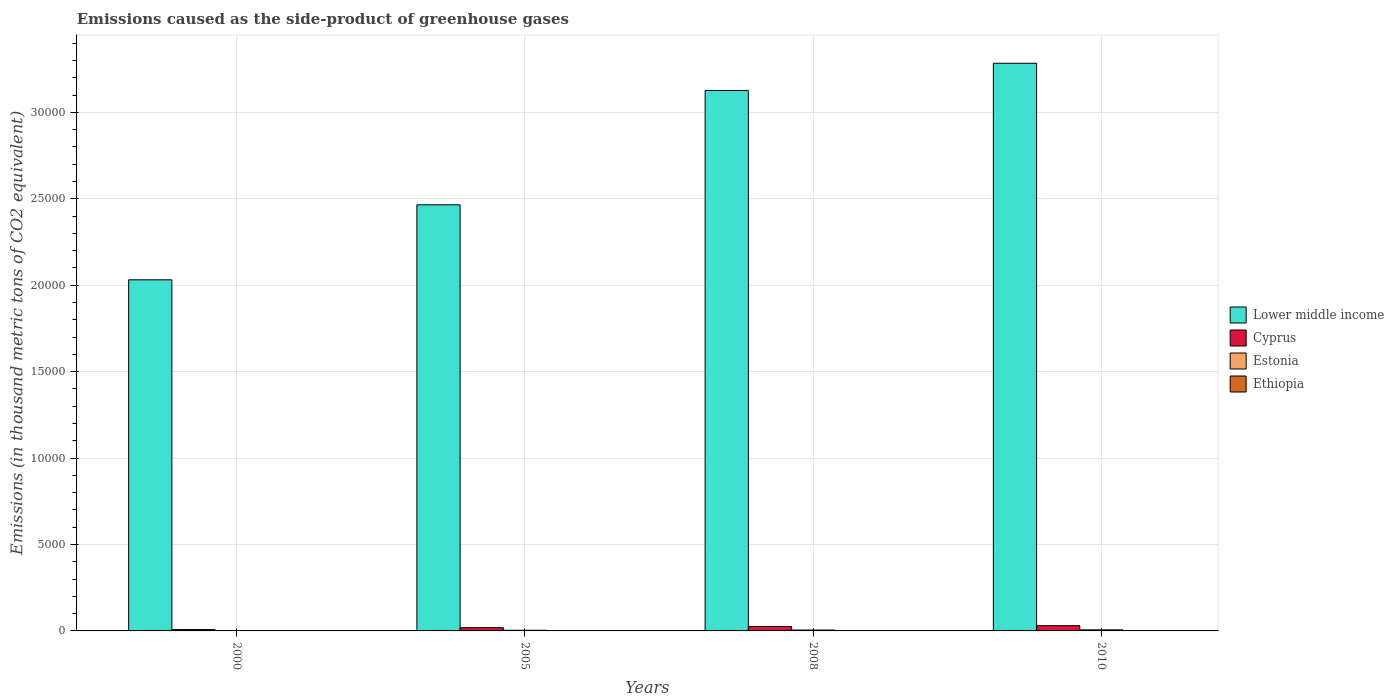How many different coloured bars are there?
Make the answer very short. 4. How many groups of bars are there?
Offer a very short reply. 4. Are the number of bars per tick equal to the number of legend labels?
Make the answer very short. Yes. How many bars are there on the 2nd tick from the left?
Provide a short and direct response. 4. What is the label of the 4th group of bars from the left?
Offer a terse response. 2010. In how many cases, is the number of bars for a given year not equal to the number of legend labels?
Your answer should be very brief. 0. What is the emissions caused as the side-product of greenhouse gases in Ethiopia in 2005?
Ensure brevity in your answer.  10.3. Across all years, what is the minimum emissions caused as the side-product of greenhouse gases in Lower middle income?
Your response must be concise. 2.03e+04. What is the total emissions caused as the side-product of greenhouse gases in Ethiopia in the graph?
Keep it short and to the point. 43.2. What is the difference between the emissions caused as the side-product of greenhouse gases in Ethiopia in 2000 and that in 2008?
Keep it short and to the point. -9.7. What is the difference between the emissions caused as the side-product of greenhouse gases in Lower middle income in 2008 and the emissions caused as the side-product of greenhouse gases in Cyprus in 2005?
Make the answer very short. 3.11e+04. In the year 2005, what is the difference between the emissions caused as the side-product of greenhouse gases in Cyprus and emissions caused as the side-product of greenhouse gases in Ethiopia?
Keep it short and to the point. 178. In how many years, is the emissions caused as the side-product of greenhouse gases in Cyprus greater than 22000 thousand metric tons?
Provide a short and direct response. 0. What is the ratio of the emissions caused as the side-product of greenhouse gases in Ethiopia in 2005 to that in 2008?
Provide a succinct answer. 0.77. Is the emissions caused as the side-product of greenhouse gases in Ethiopia in 2000 less than that in 2008?
Your response must be concise. Yes. What is the difference between the highest and the second highest emissions caused as the side-product of greenhouse gases in Lower middle income?
Offer a terse response. 1576. What is the difference between the highest and the lowest emissions caused as the side-product of greenhouse gases in Lower middle income?
Your answer should be compact. 1.25e+04. In how many years, is the emissions caused as the side-product of greenhouse gases in Lower middle income greater than the average emissions caused as the side-product of greenhouse gases in Lower middle income taken over all years?
Your response must be concise. 2. Is the sum of the emissions caused as the side-product of greenhouse gases in Cyprus in 2005 and 2008 greater than the maximum emissions caused as the side-product of greenhouse gases in Estonia across all years?
Make the answer very short. Yes. What does the 3rd bar from the left in 2008 represents?
Your response must be concise. Estonia. What does the 1st bar from the right in 2010 represents?
Provide a succinct answer. Ethiopia. Is it the case that in every year, the sum of the emissions caused as the side-product of greenhouse gases in Lower middle income and emissions caused as the side-product of greenhouse gases in Cyprus is greater than the emissions caused as the side-product of greenhouse gases in Estonia?
Provide a short and direct response. Yes. How many years are there in the graph?
Make the answer very short. 4. Are the values on the major ticks of Y-axis written in scientific E-notation?
Make the answer very short. No. Does the graph contain any zero values?
Make the answer very short. No. Does the graph contain grids?
Provide a succinct answer. Yes. Where does the legend appear in the graph?
Your answer should be very brief. Center right. How many legend labels are there?
Ensure brevity in your answer.  4. How are the legend labels stacked?
Offer a terse response. Vertical. What is the title of the graph?
Give a very brief answer. Emissions caused as the side-product of greenhouse gases. Does "Sint Maarten (Dutch part)" appear as one of the legend labels in the graph?
Provide a succinct answer. No. What is the label or title of the Y-axis?
Give a very brief answer. Emissions (in thousand metric tons of CO2 equivalent). What is the Emissions (in thousand metric tons of CO2 equivalent) in Lower middle income in 2000?
Give a very brief answer. 2.03e+04. What is the Emissions (in thousand metric tons of CO2 equivalent) in Cyprus in 2000?
Your answer should be very brief. 78.4. What is the Emissions (in thousand metric tons of CO2 equivalent) of Lower middle income in 2005?
Your answer should be very brief. 2.47e+04. What is the Emissions (in thousand metric tons of CO2 equivalent) in Cyprus in 2005?
Your response must be concise. 188.3. What is the Emissions (in thousand metric tons of CO2 equivalent) of Estonia in 2005?
Your answer should be compact. 39.4. What is the Emissions (in thousand metric tons of CO2 equivalent) of Ethiopia in 2005?
Offer a very short reply. 10.3. What is the Emissions (in thousand metric tons of CO2 equivalent) in Lower middle income in 2008?
Your response must be concise. 3.13e+04. What is the Emissions (in thousand metric tons of CO2 equivalent) in Cyprus in 2008?
Your answer should be very brief. 256.1. What is the Emissions (in thousand metric tons of CO2 equivalent) in Estonia in 2008?
Provide a short and direct response. 53.3. What is the Emissions (in thousand metric tons of CO2 equivalent) of Lower middle income in 2010?
Offer a very short reply. 3.28e+04. What is the Emissions (in thousand metric tons of CO2 equivalent) in Cyprus in 2010?
Keep it short and to the point. 304. What is the Emissions (in thousand metric tons of CO2 equivalent) in Estonia in 2010?
Your answer should be very brief. 63. What is the Emissions (in thousand metric tons of CO2 equivalent) in Ethiopia in 2010?
Keep it short and to the point. 16. Across all years, what is the maximum Emissions (in thousand metric tons of CO2 equivalent) in Lower middle income?
Offer a terse response. 3.28e+04. Across all years, what is the maximum Emissions (in thousand metric tons of CO2 equivalent) of Cyprus?
Ensure brevity in your answer.  304. Across all years, what is the maximum Emissions (in thousand metric tons of CO2 equivalent) in Ethiopia?
Your response must be concise. 16. Across all years, what is the minimum Emissions (in thousand metric tons of CO2 equivalent) of Lower middle income?
Ensure brevity in your answer.  2.03e+04. Across all years, what is the minimum Emissions (in thousand metric tons of CO2 equivalent) in Cyprus?
Give a very brief answer. 78.4. Across all years, what is the minimum Emissions (in thousand metric tons of CO2 equivalent) in Estonia?
Make the answer very short. 13.3. Across all years, what is the minimum Emissions (in thousand metric tons of CO2 equivalent) in Ethiopia?
Keep it short and to the point. 3.6. What is the total Emissions (in thousand metric tons of CO2 equivalent) of Lower middle income in the graph?
Ensure brevity in your answer.  1.09e+05. What is the total Emissions (in thousand metric tons of CO2 equivalent) of Cyprus in the graph?
Make the answer very short. 826.8. What is the total Emissions (in thousand metric tons of CO2 equivalent) in Estonia in the graph?
Give a very brief answer. 169. What is the total Emissions (in thousand metric tons of CO2 equivalent) in Ethiopia in the graph?
Make the answer very short. 43.2. What is the difference between the Emissions (in thousand metric tons of CO2 equivalent) of Lower middle income in 2000 and that in 2005?
Make the answer very short. -4339.1. What is the difference between the Emissions (in thousand metric tons of CO2 equivalent) of Cyprus in 2000 and that in 2005?
Ensure brevity in your answer.  -109.9. What is the difference between the Emissions (in thousand metric tons of CO2 equivalent) in Estonia in 2000 and that in 2005?
Offer a terse response. -26.1. What is the difference between the Emissions (in thousand metric tons of CO2 equivalent) of Ethiopia in 2000 and that in 2005?
Offer a very short reply. -6.7. What is the difference between the Emissions (in thousand metric tons of CO2 equivalent) of Lower middle income in 2000 and that in 2008?
Make the answer very short. -1.10e+04. What is the difference between the Emissions (in thousand metric tons of CO2 equivalent) in Cyprus in 2000 and that in 2008?
Your response must be concise. -177.7. What is the difference between the Emissions (in thousand metric tons of CO2 equivalent) in Estonia in 2000 and that in 2008?
Give a very brief answer. -40. What is the difference between the Emissions (in thousand metric tons of CO2 equivalent) in Ethiopia in 2000 and that in 2008?
Keep it short and to the point. -9.7. What is the difference between the Emissions (in thousand metric tons of CO2 equivalent) of Lower middle income in 2000 and that in 2010?
Ensure brevity in your answer.  -1.25e+04. What is the difference between the Emissions (in thousand metric tons of CO2 equivalent) in Cyprus in 2000 and that in 2010?
Your answer should be very brief. -225.6. What is the difference between the Emissions (in thousand metric tons of CO2 equivalent) in Estonia in 2000 and that in 2010?
Make the answer very short. -49.7. What is the difference between the Emissions (in thousand metric tons of CO2 equivalent) in Lower middle income in 2005 and that in 2008?
Offer a very short reply. -6613.6. What is the difference between the Emissions (in thousand metric tons of CO2 equivalent) of Cyprus in 2005 and that in 2008?
Provide a succinct answer. -67.8. What is the difference between the Emissions (in thousand metric tons of CO2 equivalent) in Estonia in 2005 and that in 2008?
Your answer should be compact. -13.9. What is the difference between the Emissions (in thousand metric tons of CO2 equivalent) of Lower middle income in 2005 and that in 2010?
Provide a short and direct response. -8189.6. What is the difference between the Emissions (in thousand metric tons of CO2 equivalent) in Cyprus in 2005 and that in 2010?
Your answer should be compact. -115.7. What is the difference between the Emissions (in thousand metric tons of CO2 equivalent) of Estonia in 2005 and that in 2010?
Ensure brevity in your answer.  -23.6. What is the difference between the Emissions (in thousand metric tons of CO2 equivalent) in Ethiopia in 2005 and that in 2010?
Provide a short and direct response. -5.7. What is the difference between the Emissions (in thousand metric tons of CO2 equivalent) of Lower middle income in 2008 and that in 2010?
Ensure brevity in your answer.  -1576. What is the difference between the Emissions (in thousand metric tons of CO2 equivalent) in Cyprus in 2008 and that in 2010?
Your answer should be very brief. -47.9. What is the difference between the Emissions (in thousand metric tons of CO2 equivalent) of Lower middle income in 2000 and the Emissions (in thousand metric tons of CO2 equivalent) of Cyprus in 2005?
Ensure brevity in your answer.  2.01e+04. What is the difference between the Emissions (in thousand metric tons of CO2 equivalent) in Lower middle income in 2000 and the Emissions (in thousand metric tons of CO2 equivalent) in Estonia in 2005?
Your response must be concise. 2.03e+04. What is the difference between the Emissions (in thousand metric tons of CO2 equivalent) in Lower middle income in 2000 and the Emissions (in thousand metric tons of CO2 equivalent) in Ethiopia in 2005?
Your response must be concise. 2.03e+04. What is the difference between the Emissions (in thousand metric tons of CO2 equivalent) of Cyprus in 2000 and the Emissions (in thousand metric tons of CO2 equivalent) of Ethiopia in 2005?
Keep it short and to the point. 68.1. What is the difference between the Emissions (in thousand metric tons of CO2 equivalent) in Lower middle income in 2000 and the Emissions (in thousand metric tons of CO2 equivalent) in Cyprus in 2008?
Your response must be concise. 2.01e+04. What is the difference between the Emissions (in thousand metric tons of CO2 equivalent) in Lower middle income in 2000 and the Emissions (in thousand metric tons of CO2 equivalent) in Estonia in 2008?
Offer a terse response. 2.03e+04. What is the difference between the Emissions (in thousand metric tons of CO2 equivalent) in Lower middle income in 2000 and the Emissions (in thousand metric tons of CO2 equivalent) in Ethiopia in 2008?
Your response must be concise. 2.03e+04. What is the difference between the Emissions (in thousand metric tons of CO2 equivalent) of Cyprus in 2000 and the Emissions (in thousand metric tons of CO2 equivalent) of Estonia in 2008?
Offer a very short reply. 25.1. What is the difference between the Emissions (in thousand metric tons of CO2 equivalent) of Cyprus in 2000 and the Emissions (in thousand metric tons of CO2 equivalent) of Ethiopia in 2008?
Provide a succinct answer. 65.1. What is the difference between the Emissions (in thousand metric tons of CO2 equivalent) in Lower middle income in 2000 and the Emissions (in thousand metric tons of CO2 equivalent) in Cyprus in 2010?
Offer a very short reply. 2.00e+04. What is the difference between the Emissions (in thousand metric tons of CO2 equivalent) in Lower middle income in 2000 and the Emissions (in thousand metric tons of CO2 equivalent) in Estonia in 2010?
Your answer should be compact. 2.03e+04. What is the difference between the Emissions (in thousand metric tons of CO2 equivalent) in Lower middle income in 2000 and the Emissions (in thousand metric tons of CO2 equivalent) in Ethiopia in 2010?
Keep it short and to the point. 2.03e+04. What is the difference between the Emissions (in thousand metric tons of CO2 equivalent) of Cyprus in 2000 and the Emissions (in thousand metric tons of CO2 equivalent) of Estonia in 2010?
Provide a short and direct response. 15.4. What is the difference between the Emissions (in thousand metric tons of CO2 equivalent) of Cyprus in 2000 and the Emissions (in thousand metric tons of CO2 equivalent) of Ethiopia in 2010?
Your answer should be very brief. 62.4. What is the difference between the Emissions (in thousand metric tons of CO2 equivalent) in Lower middle income in 2005 and the Emissions (in thousand metric tons of CO2 equivalent) in Cyprus in 2008?
Keep it short and to the point. 2.44e+04. What is the difference between the Emissions (in thousand metric tons of CO2 equivalent) in Lower middle income in 2005 and the Emissions (in thousand metric tons of CO2 equivalent) in Estonia in 2008?
Provide a succinct answer. 2.46e+04. What is the difference between the Emissions (in thousand metric tons of CO2 equivalent) in Lower middle income in 2005 and the Emissions (in thousand metric tons of CO2 equivalent) in Ethiopia in 2008?
Ensure brevity in your answer.  2.46e+04. What is the difference between the Emissions (in thousand metric tons of CO2 equivalent) in Cyprus in 2005 and the Emissions (in thousand metric tons of CO2 equivalent) in Estonia in 2008?
Your response must be concise. 135. What is the difference between the Emissions (in thousand metric tons of CO2 equivalent) of Cyprus in 2005 and the Emissions (in thousand metric tons of CO2 equivalent) of Ethiopia in 2008?
Make the answer very short. 175. What is the difference between the Emissions (in thousand metric tons of CO2 equivalent) of Estonia in 2005 and the Emissions (in thousand metric tons of CO2 equivalent) of Ethiopia in 2008?
Provide a succinct answer. 26.1. What is the difference between the Emissions (in thousand metric tons of CO2 equivalent) in Lower middle income in 2005 and the Emissions (in thousand metric tons of CO2 equivalent) in Cyprus in 2010?
Offer a terse response. 2.43e+04. What is the difference between the Emissions (in thousand metric tons of CO2 equivalent) in Lower middle income in 2005 and the Emissions (in thousand metric tons of CO2 equivalent) in Estonia in 2010?
Make the answer very short. 2.46e+04. What is the difference between the Emissions (in thousand metric tons of CO2 equivalent) of Lower middle income in 2005 and the Emissions (in thousand metric tons of CO2 equivalent) of Ethiopia in 2010?
Offer a terse response. 2.46e+04. What is the difference between the Emissions (in thousand metric tons of CO2 equivalent) in Cyprus in 2005 and the Emissions (in thousand metric tons of CO2 equivalent) in Estonia in 2010?
Give a very brief answer. 125.3. What is the difference between the Emissions (in thousand metric tons of CO2 equivalent) of Cyprus in 2005 and the Emissions (in thousand metric tons of CO2 equivalent) of Ethiopia in 2010?
Provide a succinct answer. 172.3. What is the difference between the Emissions (in thousand metric tons of CO2 equivalent) of Estonia in 2005 and the Emissions (in thousand metric tons of CO2 equivalent) of Ethiopia in 2010?
Your answer should be compact. 23.4. What is the difference between the Emissions (in thousand metric tons of CO2 equivalent) of Lower middle income in 2008 and the Emissions (in thousand metric tons of CO2 equivalent) of Cyprus in 2010?
Provide a short and direct response. 3.10e+04. What is the difference between the Emissions (in thousand metric tons of CO2 equivalent) of Lower middle income in 2008 and the Emissions (in thousand metric tons of CO2 equivalent) of Estonia in 2010?
Keep it short and to the point. 3.12e+04. What is the difference between the Emissions (in thousand metric tons of CO2 equivalent) in Lower middle income in 2008 and the Emissions (in thousand metric tons of CO2 equivalent) in Ethiopia in 2010?
Your answer should be compact. 3.13e+04. What is the difference between the Emissions (in thousand metric tons of CO2 equivalent) in Cyprus in 2008 and the Emissions (in thousand metric tons of CO2 equivalent) in Estonia in 2010?
Your answer should be very brief. 193.1. What is the difference between the Emissions (in thousand metric tons of CO2 equivalent) in Cyprus in 2008 and the Emissions (in thousand metric tons of CO2 equivalent) in Ethiopia in 2010?
Your answer should be very brief. 240.1. What is the difference between the Emissions (in thousand metric tons of CO2 equivalent) in Estonia in 2008 and the Emissions (in thousand metric tons of CO2 equivalent) in Ethiopia in 2010?
Your response must be concise. 37.3. What is the average Emissions (in thousand metric tons of CO2 equivalent) of Lower middle income per year?
Give a very brief answer. 2.73e+04. What is the average Emissions (in thousand metric tons of CO2 equivalent) in Cyprus per year?
Your answer should be very brief. 206.7. What is the average Emissions (in thousand metric tons of CO2 equivalent) of Estonia per year?
Provide a short and direct response. 42.25. In the year 2000, what is the difference between the Emissions (in thousand metric tons of CO2 equivalent) in Lower middle income and Emissions (in thousand metric tons of CO2 equivalent) in Cyprus?
Keep it short and to the point. 2.02e+04. In the year 2000, what is the difference between the Emissions (in thousand metric tons of CO2 equivalent) of Lower middle income and Emissions (in thousand metric tons of CO2 equivalent) of Estonia?
Your answer should be very brief. 2.03e+04. In the year 2000, what is the difference between the Emissions (in thousand metric tons of CO2 equivalent) of Lower middle income and Emissions (in thousand metric tons of CO2 equivalent) of Ethiopia?
Your answer should be very brief. 2.03e+04. In the year 2000, what is the difference between the Emissions (in thousand metric tons of CO2 equivalent) in Cyprus and Emissions (in thousand metric tons of CO2 equivalent) in Estonia?
Give a very brief answer. 65.1. In the year 2000, what is the difference between the Emissions (in thousand metric tons of CO2 equivalent) in Cyprus and Emissions (in thousand metric tons of CO2 equivalent) in Ethiopia?
Keep it short and to the point. 74.8. In the year 2000, what is the difference between the Emissions (in thousand metric tons of CO2 equivalent) in Estonia and Emissions (in thousand metric tons of CO2 equivalent) in Ethiopia?
Your answer should be compact. 9.7. In the year 2005, what is the difference between the Emissions (in thousand metric tons of CO2 equivalent) in Lower middle income and Emissions (in thousand metric tons of CO2 equivalent) in Cyprus?
Make the answer very short. 2.45e+04. In the year 2005, what is the difference between the Emissions (in thousand metric tons of CO2 equivalent) of Lower middle income and Emissions (in thousand metric tons of CO2 equivalent) of Estonia?
Your answer should be very brief. 2.46e+04. In the year 2005, what is the difference between the Emissions (in thousand metric tons of CO2 equivalent) of Lower middle income and Emissions (in thousand metric tons of CO2 equivalent) of Ethiopia?
Your answer should be compact. 2.46e+04. In the year 2005, what is the difference between the Emissions (in thousand metric tons of CO2 equivalent) in Cyprus and Emissions (in thousand metric tons of CO2 equivalent) in Estonia?
Keep it short and to the point. 148.9. In the year 2005, what is the difference between the Emissions (in thousand metric tons of CO2 equivalent) of Cyprus and Emissions (in thousand metric tons of CO2 equivalent) of Ethiopia?
Provide a succinct answer. 178. In the year 2005, what is the difference between the Emissions (in thousand metric tons of CO2 equivalent) of Estonia and Emissions (in thousand metric tons of CO2 equivalent) of Ethiopia?
Provide a short and direct response. 29.1. In the year 2008, what is the difference between the Emissions (in thousand metric tons of CO2 equivalent) of Lower middle income and Emissions (in thousand metric tons of CO2 equivalent) of Cyprus?
Provide a succinct answer. 3.10e+04. In the year 2008, what is the difference between the Emissions (in thousand metric tons of CO2 equivalent) in Lower middle income and Emissions (in thousand metric tons of CO2 equivalent) in Estonia?
Give a very brief answer. 3.12e+04. In the year 2008, what is the difference between the Emissions (in thousand metric tons of CO2 equivalent) of Lower middle income and Emissions (in thousand metric tons of CO2 equivalent) of Ethiopia?
Your response must be concise. 3.13e+04. In the year 2008, what is the difference between the Emissions (in thousand metric tons of CO2 equivalent) of Cyprus and Emissions (in thousand metric tons of CO2 equivalent) of Estonia?
Offer a terse response. 202.8. In the year 2008, what is the difference between the Emissions (in thousand metric tons of CO2 equivalent) of Cyprus and Emissions (in thousand metric tons of CO2 equivalent) of Ethiopia?
Your response must be concise. 242.8. In the year 2010, what is the difference between the Emissions (in thousand metric tons of CO2 equivalent) in Lower middle income and Emissions (in thousand metric tons of CO2 equivalent) in Cyprus?
Provide a short and direct response. 3.25e+04. In the year 2010, what is the difference between the Emissions (in thousand metric tons of CO2 equivalent) in Lower middle income and Emissions (in thousand metric tons of CO2 equivalent) in Estonia?
Provide a short and direct response. 3.28e+04. In the year 2010, what is the difference between the Emissions (in thousand metric tons of CO2 equivalent) of Lower middle income and Emissions (in thousand metric tons of CO2 equivalent) of Ethiopia?
Ensure brevity in your answer.  3.28e+04. In the year 2010, what is the difference between the Emissions (in thousand metric tons of CO2 equivalent) of Cyprus and Emissions (in thousand metric tons of CO2 equivalent) of Estonia?
Ensure brevity in your answer.  241. In the year 2010, what is the difference between the Emissions (in thousand metric tons of CO2 equivalent) of Cyprus and Emissions (in thousand metric tons of CO2 equivalent) of Ethiopia?
Keep it short and to the point. 288. In the year 2010, what is the difference between the Emissions (in thousand metric tons of CO2 equivalent) in Estonia and Emissions (in thousand metric tons of CO2 equivalent) in Ethiopia?
Ensure brevity in your answer.  47. What is the ratio of the Emissions (in thousand metric tons of CO2 equivalent) in Lower middle income in 2000 to that in 2005?
Provide a short and direct response. 0.82. What is the ratio of the Emissions (in thousand metric tons of CO2 equivalent) in Cyprus in 2000 to that in 2005?
Give a very brief answer. 0.42. What is the ratio of the Emissions (in thousand metric tons of CO2 equivalent) in Estonia in 2000 to that in 2005?
Your answer should be compact. 0.34. What is the ratio of the Emissions (in thousand metric tons of CO2 equivalent) of Ethiopia in 2000 to that in 2005?
Provide a succinct answer. 0.35. What is the ratio of the Emissions (in thousand metric tons of CO2 equivalent) in Lower middle income in 2000 to that in 2008?
Provide a succinct answer. 0.65. What is the ratio of the Emissions (in thousand metric tons of CO2 equivalent) of Cyprus in 2000 to that in 2008?
Keep it short and to the point. 0.31. What is the ratio of the Emissions (in thousand metric tons of CO2 equivalent) of Estonia in 2000 to that in 2008?
Your answer should be compact. 0.25. What is the ratio of the Emissions (in thousand metric tons of CO2 equivalent) in Ethiopia in 2000 to that in 2008?
Your response must be concise. 0.27. What is the ratio of the Emissions (in thousand metric tons of CO2 equivalent) in Lower middle income in 2000 to that in 2010?
Offer a terse response. 0.62. What is the ratio of the Emissions (in thousand metric tons of CO2 equivalent) of Cyprus in 2000 to that in 2010?
Offer a very short reply. 0.26. What is the ratio of the Emissions (in thousand metric tons of CO2 equivalent) in Estonia in 2000 to that in 2010?
Give a very brief answer. 0.21. What is the ratio of the Emissions (in thousand metric tons of CO2 equivalent) of Ethiopia in 2000 to that in 2010?
Your response must be concise. 0.23. What is the ratio of the Emissions (in thousand metric tons of CO2 equivalent) of Lower middle income in 2005 to that in 2008?
Offer a very short reply. 0.79. What is the ratio of the Emissions (in thousand metric tons of CO2 equivalent) in Cyprus in 2005 to that in 2008?
Your answer should be compact. 0.74. What is the ratio of the Emissions (in thousand metric tons of CO2 equivalent) of Estonia in 2005 to that in 2008?
Give a very brief answer. 0.74. What is the ratio of the Emissions (in thousand metric tons of CO2 equivalent) of Ethiopia in 2005 to that in 2008?
Offer a terse response. 0.77. What is the ratio of the Emissions (in thousand metric tons of CO2 equivalent) in Lower middle income in 2005 to that in 2010?
Ensure brevity in your answer.  0.75. What is the ratio of the Emissions (in thousand metric tons of CO2 equivalent) in Cyprus in 2005 to that in 2010?
Your answer should be very brief. 0.62. What is the ratio of the Emissions (in thousand metric tons of CO2 equivalent) in Estonia in 2005 to that in 2010?
Your response must be concise. 0.63. What is the ratio of the Emissions (in thousand metric tons of CO2 equivalent) in Ethiopia in 2005 to that in 2010?
Give a very brief answer. 0.64. What is the ratio of the Emissions (in thousand metric tons of CO2 equivalent) in Cyprus in 2008 to that in 2010?
Your answer should be compact. 0.84. What is the ratio of the Emissions (in thousand metric tons of CO2 equivalent) in Estonia in 2008 to that in 2010?
Ensure brevity in your answer.  0.85. What is the ratio of the Emissions (in thousand metric tons of CO2 equivalent) in Ethiopia in 2008 to that in 2010?
Provide a succinct answer. 0.83. What is the difference between the highest and the second highest Emissions (in thousand metric tons of CO2 equivalent) of Lower middle income?
Ensure brevity in your answer.  1576. What is the difference between the highest and the second highest Emissions (in thousand metric tons of CO2 equivalent) of Cyprus?
Offer a terse response. 47.9. What is the difference between the highest and the second highest Emissions (in thousand metric tons of CO2 equivalent) of Estonia?
Offer a very short reply. 9.7. What is the difference between the highest and the lowest Emissions (in thousand metric tons of CO2 equivalent) in Lower middle income?
Ensure brevity in your answer.  1.25e+04. What is the difference between the highest and the lowest Emissions (in thousand metric tons of CO2 equivalent) in Cyprus?
Your answer should be very brief. 225.6. What is the difference between the highest and the lowest Emissions (in thousand metric tons of CO2 equivalent) in Estonia?
Provide a succinct answer. 49.7. What is the difference between the highest and the lowest Emissions (in thousand metric tons of CO2 equivalent) of Ethiopia?
Offer a very short reply. 12.4. 